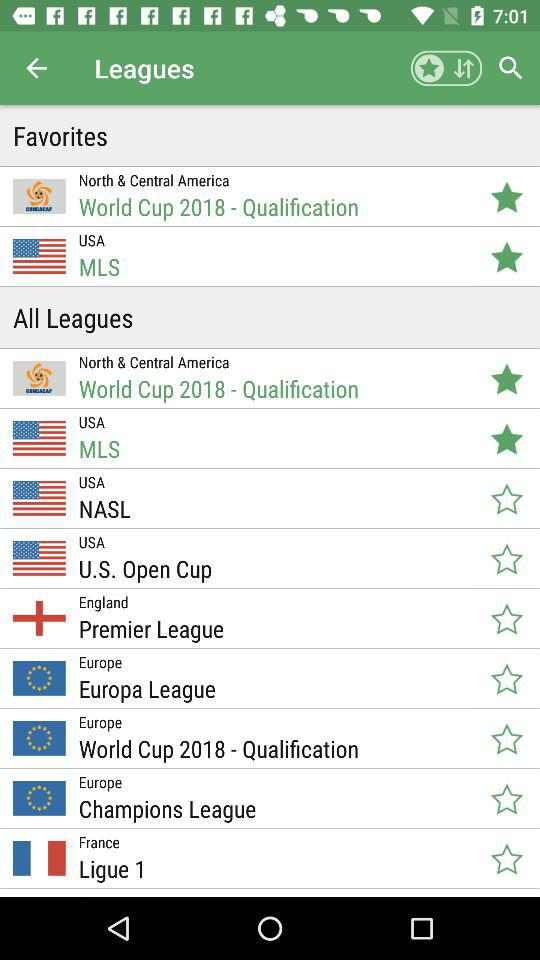What options are marked as favorites in the application? The options that are marked as favorites in the application are "World Cup 2018 - Qualification" and "MLS". 